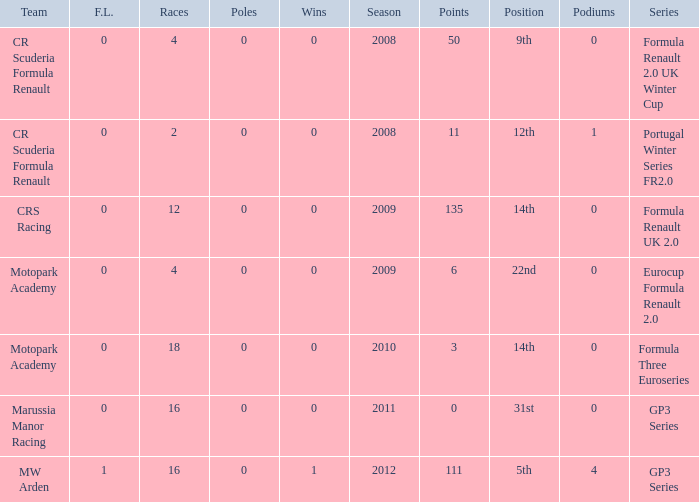How many points does Marussia Manor Racing have? 1.0. 